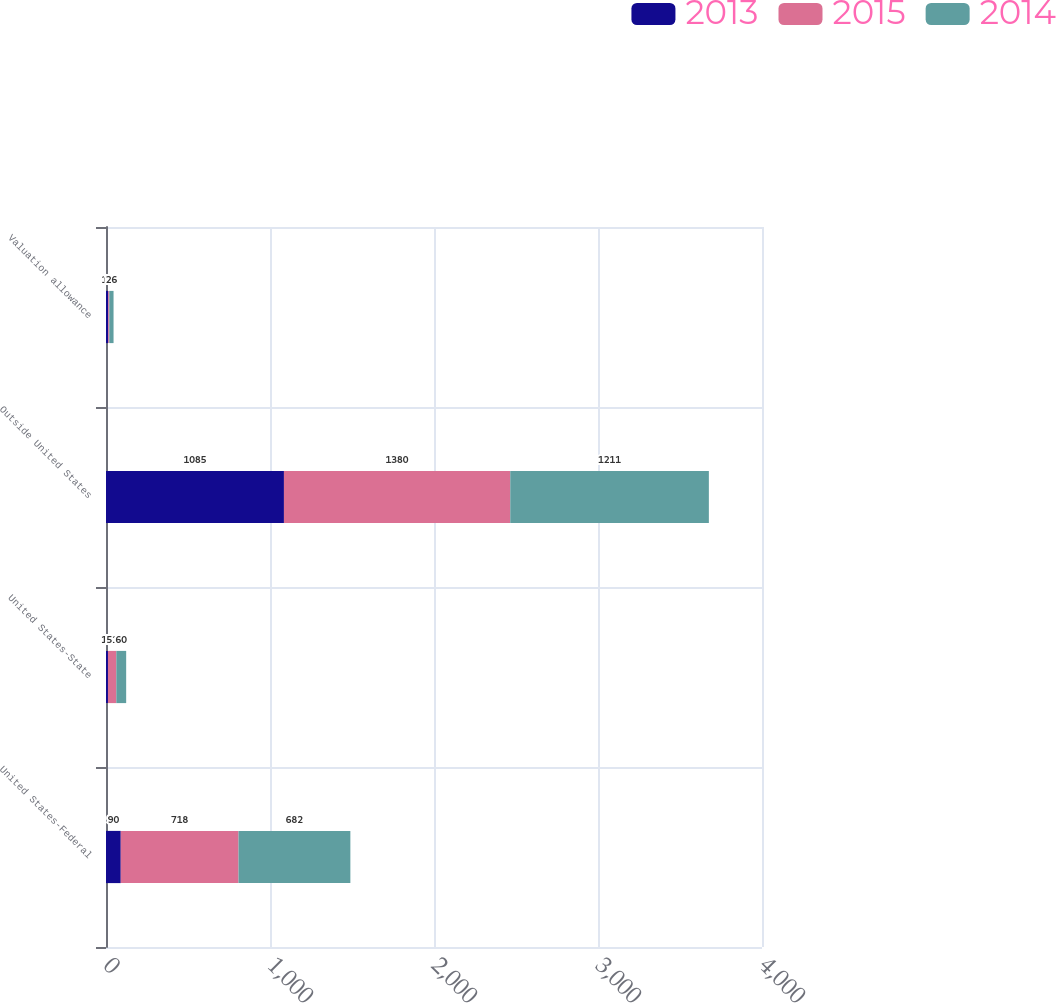Convert chart to OTSL. <chart><loc_0><loc_0><loc_500><loc_500><stacked_bar_chart><ecel><fcel>United States-Federal<fcel>United States-State<fcel>Outside United States<fcel>Valuation allowance<nl><fcel>2013<fcel>90<fcel>12<fcel>1085<fcel>14<nl><fcel>2015<fcel>718<fcel>51<fcel>1380<fcel>6<nl><fcel>2014<fcel>682<fcel>60<fcel>1211<fcel>26<nl></chart> 